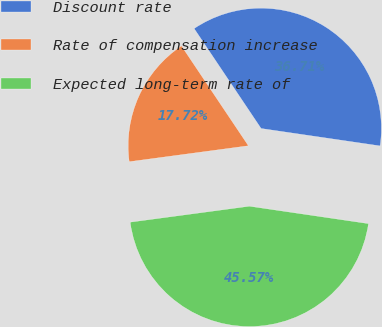Convert chart to OTSL. <chart><loc_0><loc_0><loc_500><loc_500><pie_chart><fcel>Discount rate<fcel>Rate of compensation increase<fcel>Expected long-term rate of<nl><fcel>36.71%<fcel>17.72%<fcel>45.57%<nl></chart> 